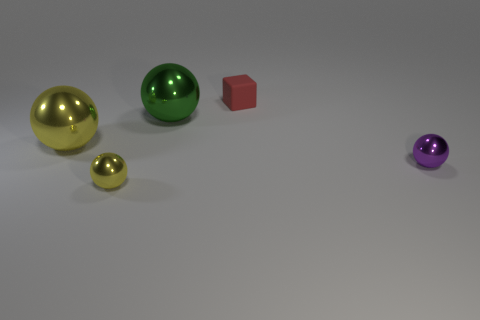Add 2 blocks. How many objects exist? 7 Subtract all cubes. How many objects are left? 4 Subtract all green balls. Subtract all purple shiny objects. How many objects are left? 3 Add 1 yellow shiny things. How many yellow shiny things are left? 3 Add 1 matte blocks. How many matte blocks exist? 2 Subtract 0 brown cylinders. How many objects are left? 5 